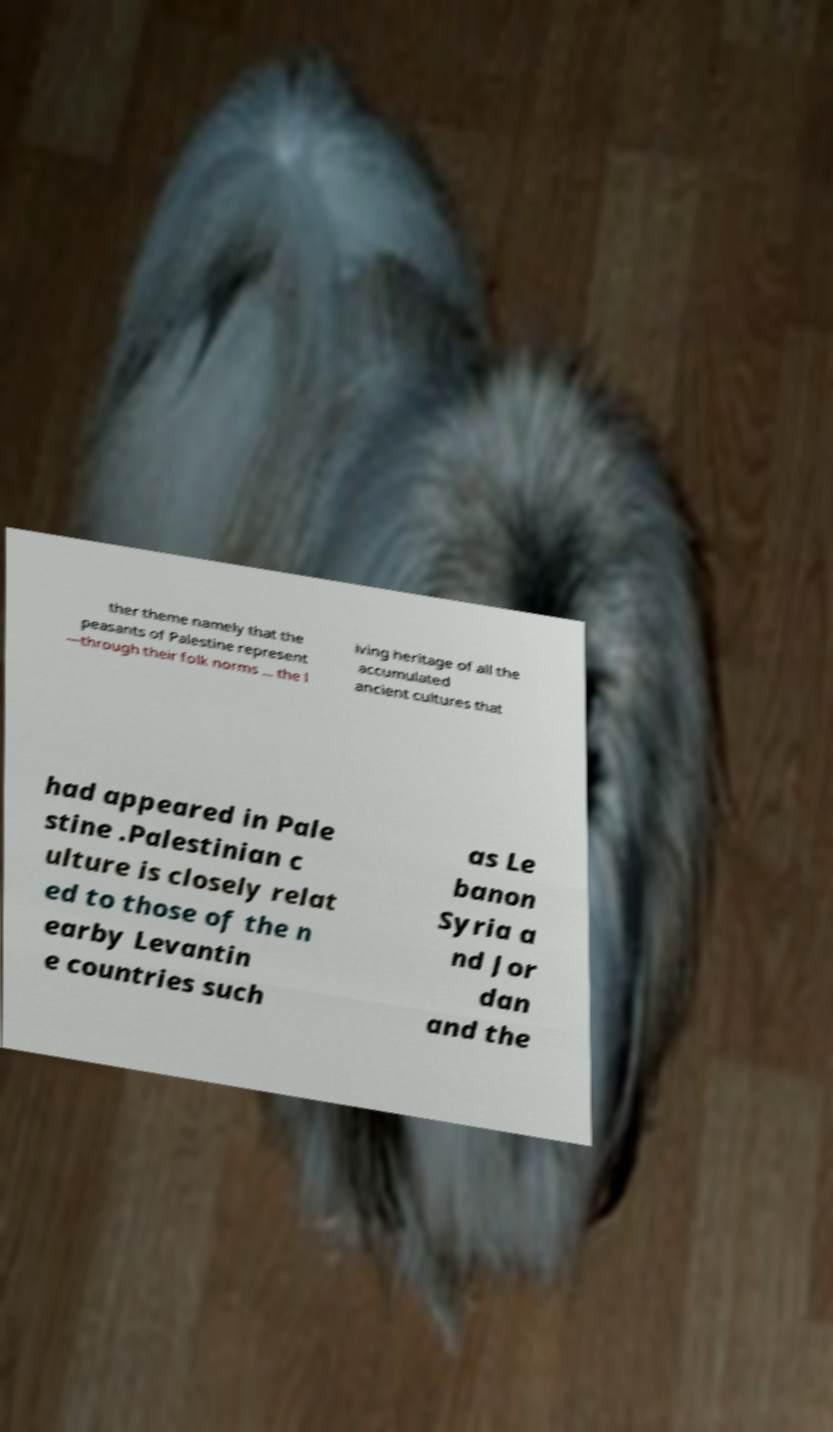There's text embedded in this image that I need extracted. Can you transcribe it verbatim? ther theme namely that the peasants of Palestine represent —through their folk norms ... the l iving heritage of all the accumulated ancient cultures that had appeared in Pale stine .Palestinian c ulture is closely relat ed to those of the n earby Levantin e countries such as Le banon Syria a nd Jor dan and the 